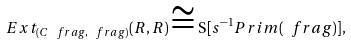<formula> <loc_0><loc_0><loc_500><loc_500>E x t _ { ( C \ f r a g , \ f r a g ) } ( R , R ) \cong \mathrm S [ s ^ { - 1 } P r i m ( \ f r a g ) ] ,</formula> 